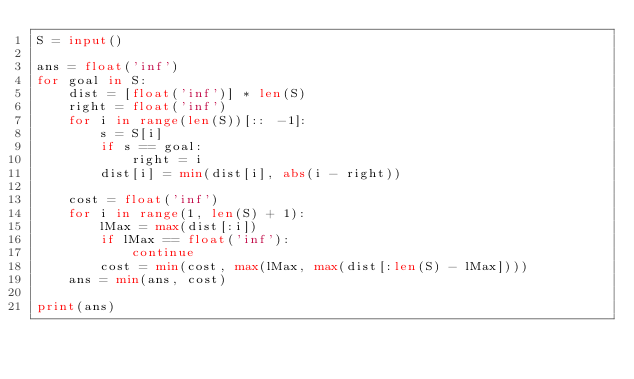Convert code to text. <code><loc_0><loc_0><loc_500><loc_500><_Python_>S = input()

ans = float('inf')
for goal in S:
    dist = [float('inf')] * len(S)
    right = float('inf')
    for i in range(len(S))[:: -1]:
        s = S[i]
        if s == goal:
            right = i
        dist[i] = min(dist[i], abs(i - right))

    cost = float('inf')
    for i in range(1, len(S) + 1):
        lMax = max(dist[:i])
        if lMax == float('inf'):
            continue
        cost = min(cost, max(lMax, max(dist[:len(S) - lMax])))
    ans = min(ans, cost)

print(ans)</code> 